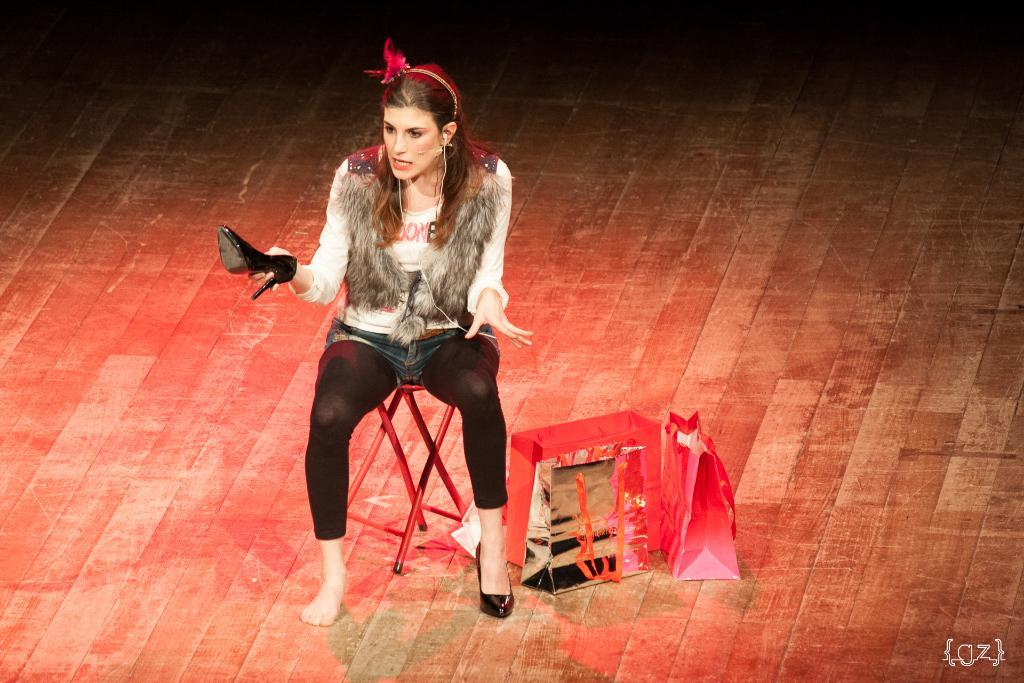What is the girl doing in the image? The girl is sitting on a stool in the image. What objects are near the girl? There are covers beside the girl. What is the woman in the image doing? The woman is holding shoes in the image. How does the cactus help the girl in the image? There is no cactus present in the image, so it cannot help the girl. 